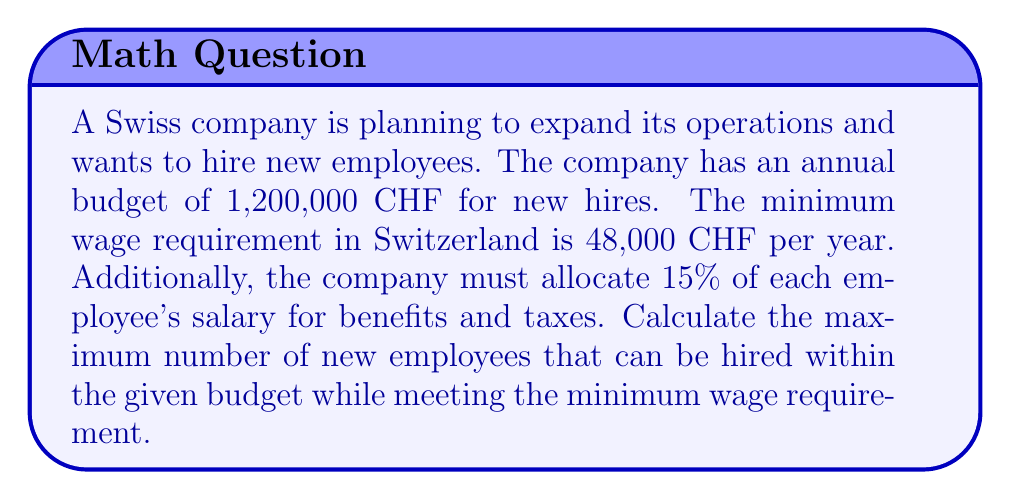Solve this math problem. Let's approach this step-by-step:

1) First, we need to calculate the total cost per employee:
   Minimum wage: 48,000 CHF
   Benefits and taxes: 15% of 48,000 = 0.15 × 48,000 = 7,200 CHF
   Total cost per employee: 48,000 + 7,200 = 55,200 CHF

2) Now, we can set up an inequality:
   Let $x$ be the number of employees
   $55,200x \leq 1,200,000$

3) Solve the inequality:
   $$55,200x \leq 1,200,000$$
   $$x \leq \frac{1,200,000}{55,200}$$
   $$x \leq 21.739$$

4) Since we can't hire a fraction of an employee, we need to round down to the nearest whole number.

5) Therefore, the maximum number of employees that can be hired is 21.
Answer: 21 employees 